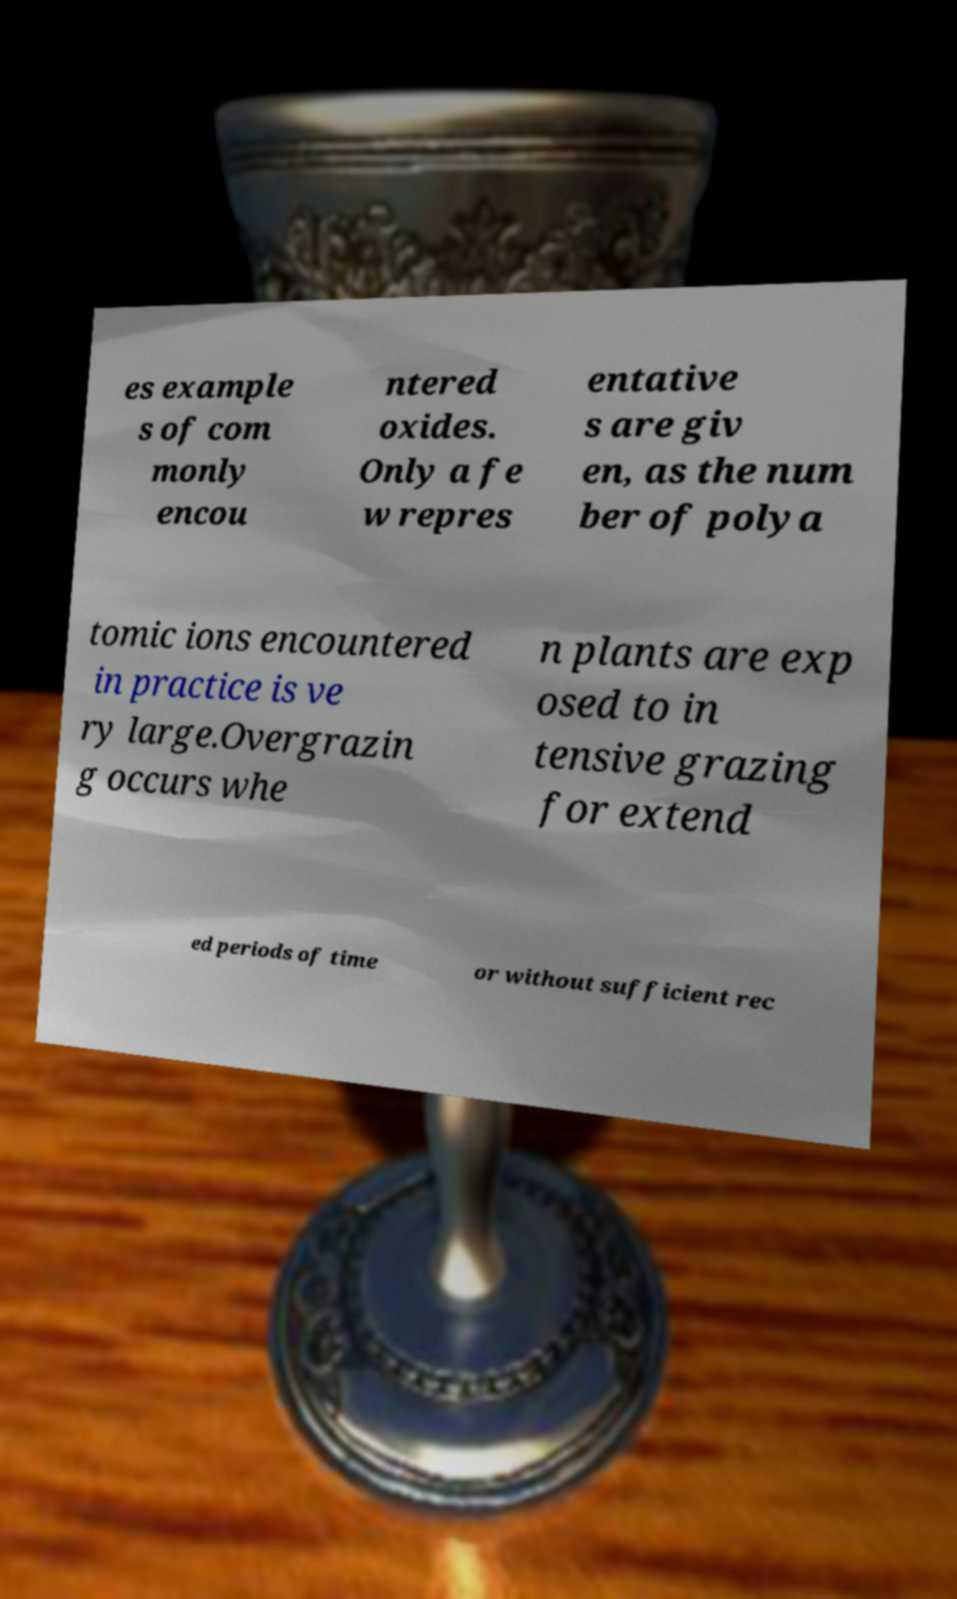Please read and relay the text visible in this image. What does it say? es example s of com monly encou ntered oxides. Only a fe w repres entative s are giv en, as the num ber of polya tomic ions encountered in practice is ve ry large.Overgrazin g occurs whe n plants are exp osed to in tensive grazing for extend ed periods of time or without sufficient rec 